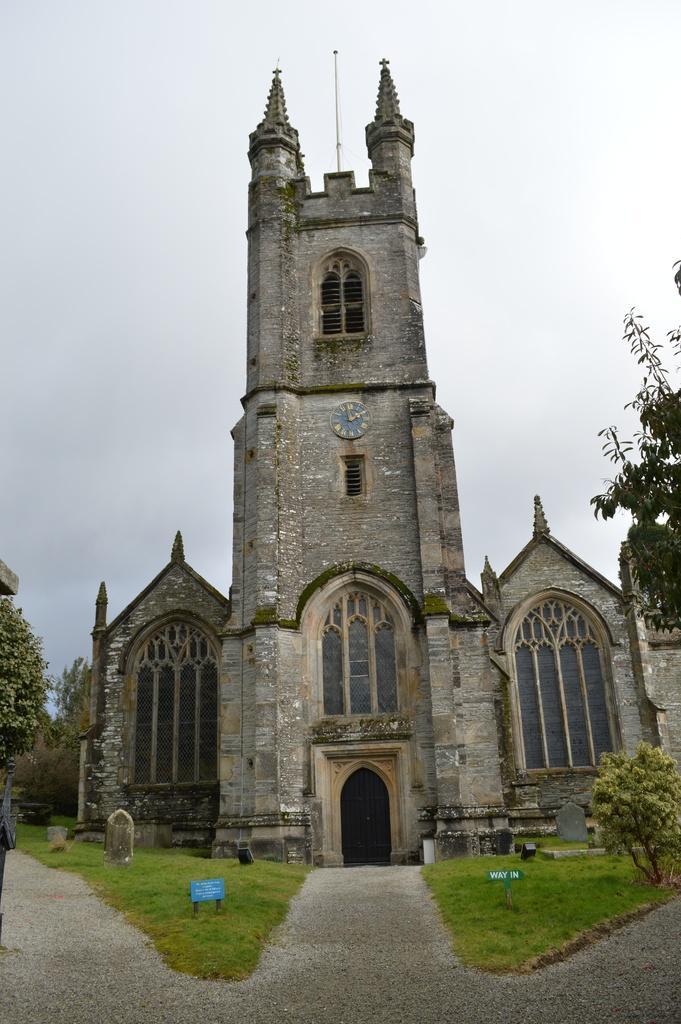How would you summarize this image in a sentence or two? In this image, we can see a building, walls, windows, doors lock and pillars. On the right side and left side, we can see trees. Here we can see plants, grass and few boards. At the bottom of the image, we can see walkways. Here we can see few objects in the image. Background there is the sky. Top of the image, we can see pole and holy crosses. 